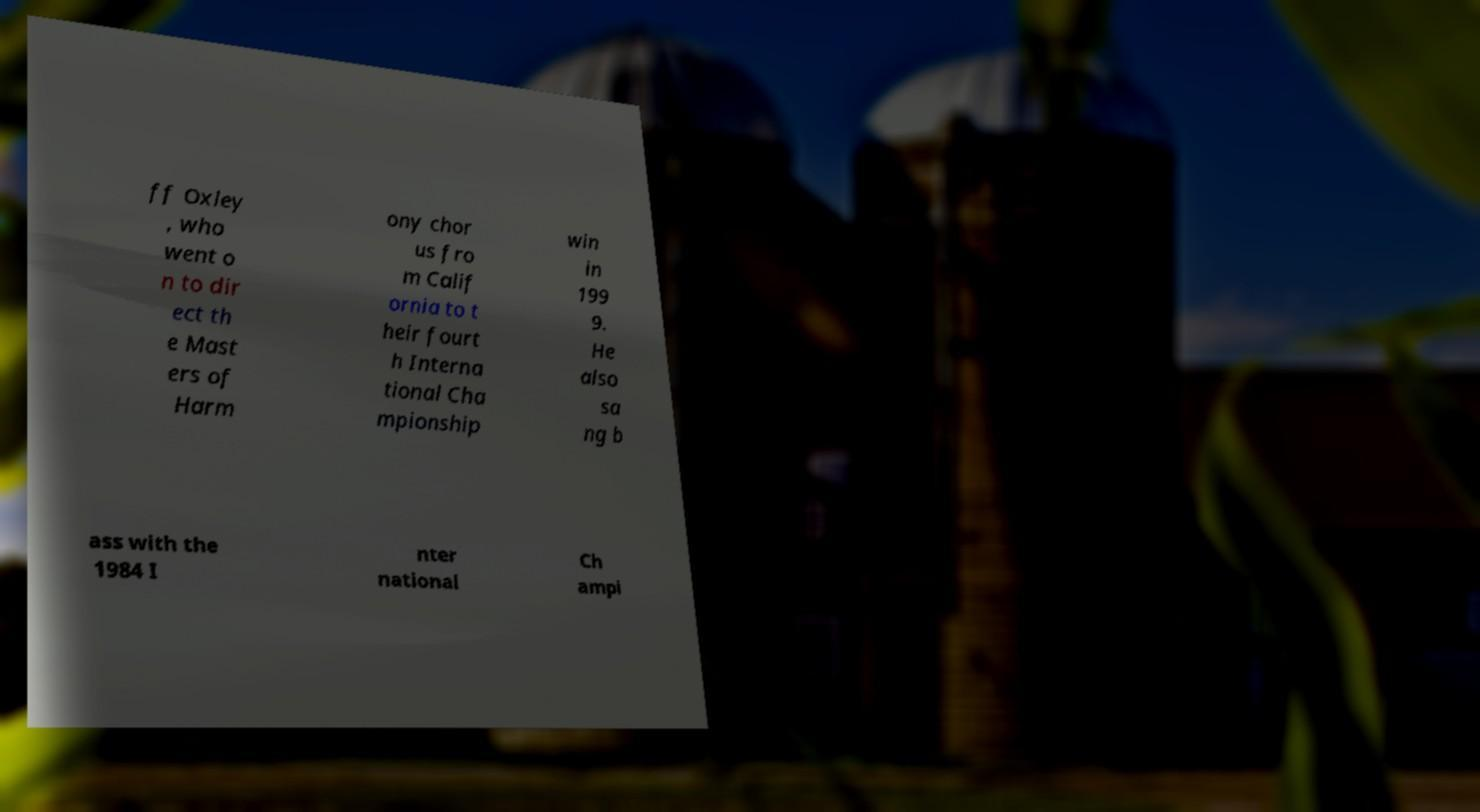Could you assist in decoding the text presented in this image and type it out clearly? ff Oxley , who went o n to dir ect th e Mast ers of Harm ony chor us fro m Calif ornia to t heir fourt h Interna tional Cha mpionship win in 199 9. He also sa ng b ass with the 1984 I nter national Ch ampi 